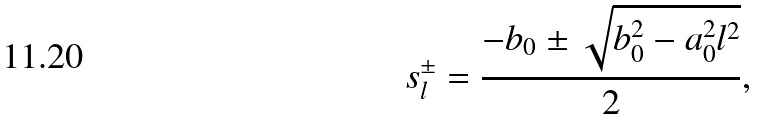<formula> <loc_0><loc_0><loc_500><loc_500>s _ { l } ^ { \pm } = \frac { - b _ { 0 } \pm \sqrt { b _ { 0 } ^ { 2 } - a _ { 0 } ^ { 2 } l ^ { 2 } } } { 2 } ,</formula> 